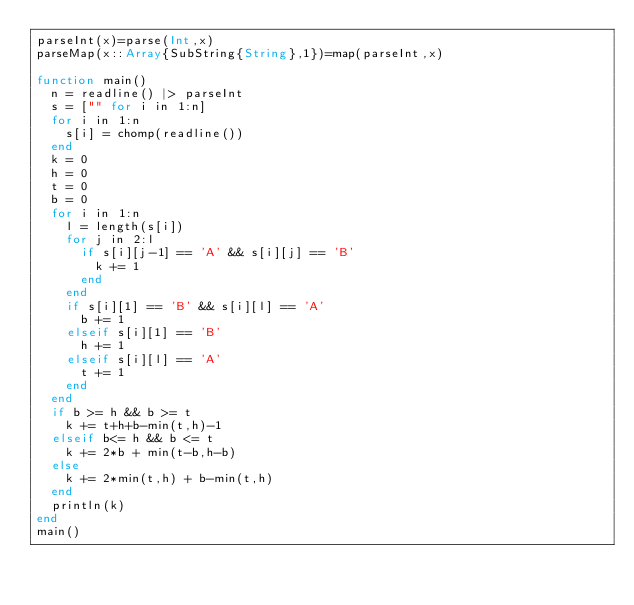<code> <loc_0><loc_0><loc_500><loc_500><_Julia_>parseInt(x)=parse(Int,x)
parseMap(x::Array{SubString{String},1})=map(parseInt,x)

function main()
	n = readline() |> parseInt
	s = ["" for i in 1:n]
	for i in 1:n
		s[i] = chomp(readline())
	end
	k = 0
	h = 0
	t = 0
	b = 0
	for i in 1:n
		l = length(s[i])
		for j in 2:l
			if s[i][j-1] == 'A' && s[i][j] == 'B'
				k += 1
			end
		end
		if s[i][1] == 'B' && s[i][l] == 'A'
			b += 1
		elseif s[i][1] == 'B'
			h += 1
		elseif s[i][l] == 'A'
			t += 1
		end
	end
	if b >= h && b >= t
		k += t+h+b-min(t,h)-1
	elseif b<= h && b <= t
		k += 2*b + min(t-b,h-b)
	else
		k += 2*min(t,h) + b-min(t,h)
	end
	println(k)
end
main()
</code> 